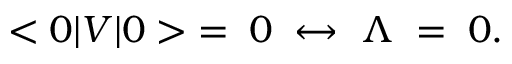<formula> <loc_0><loc_0><loc_500><loc_500>< 0 | V | 0 > \, = \, 0 \, \leftrightarrow \, \Lambda \, = \, 0 .</formula> 